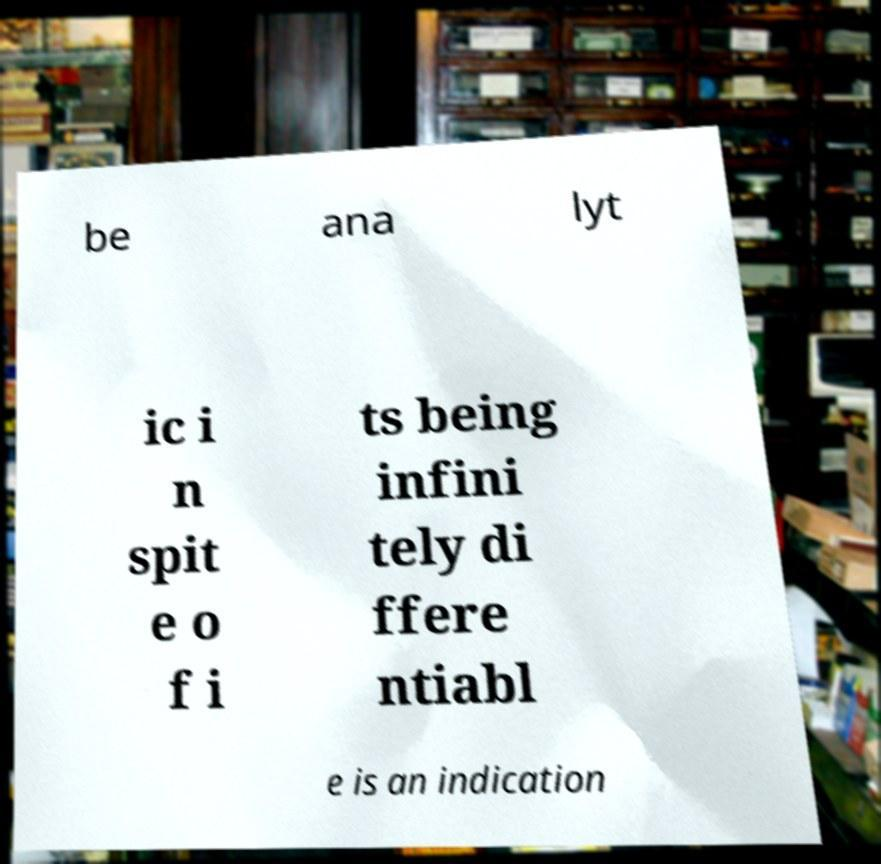Can you accurately transcribe the text from the provided image for me? be ana lyt ic i n spit e o f i ts being infini tely di ffere ntiabl e is an indication 